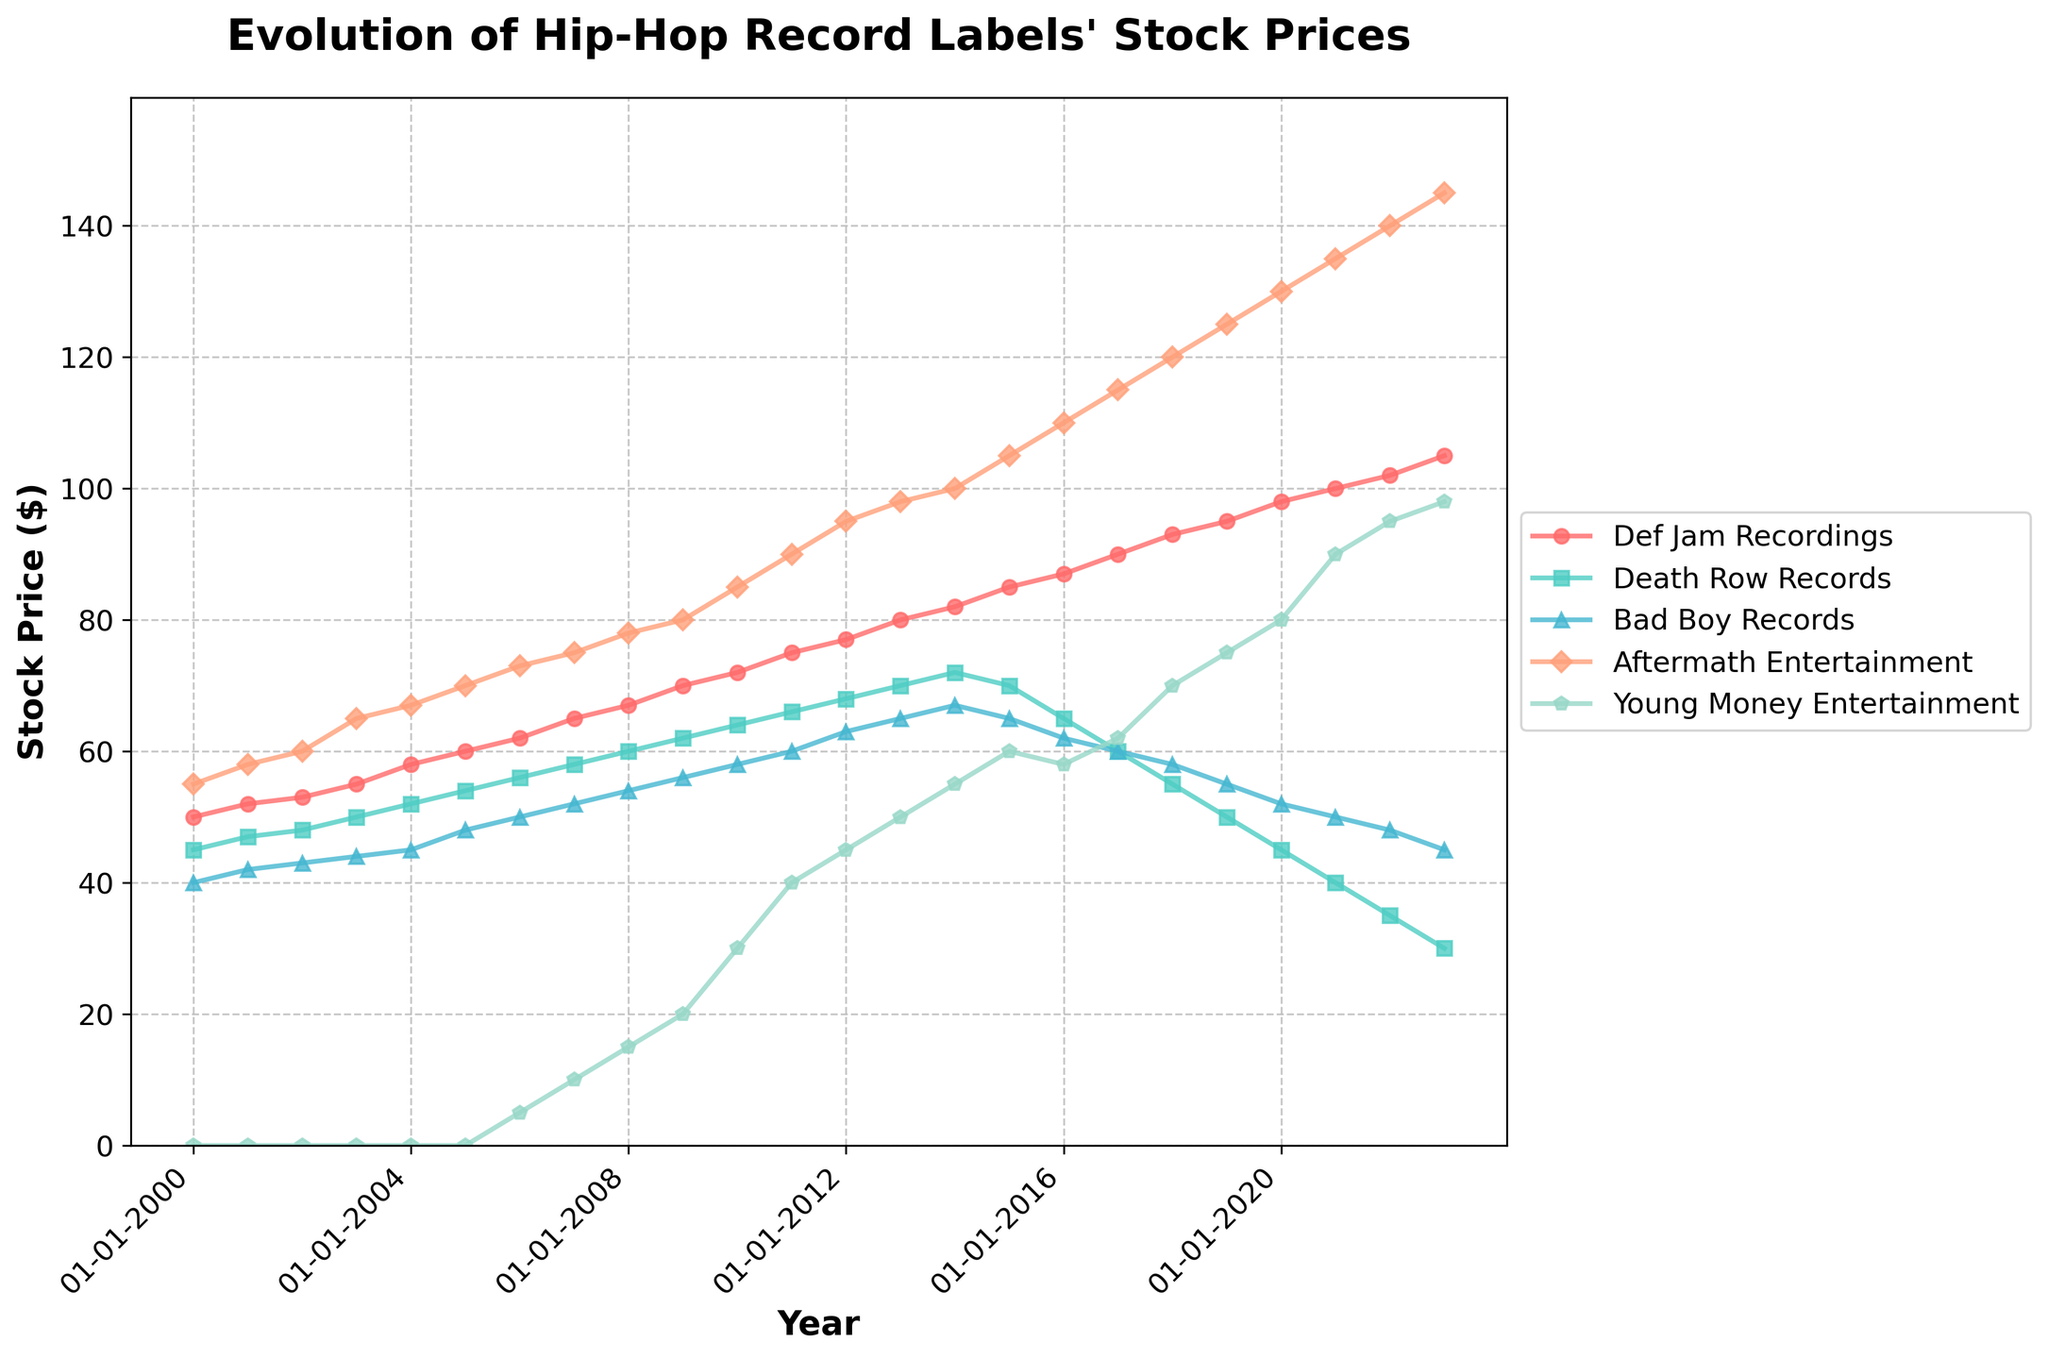What's the title of the figure? The title is typically located at the top of the figure and describes what the plot represents. In this case, it reads "Evolution of Hip-Hop Record Labels' Stock Prices".
Answer: Evolution of Hip-Hop Record Labels' Stock Prices Which record label shows a consistent yearly increase in stock price from 2000 to 2023? By observing the trends in the lines, Def Jam Recordings displays a consistent increase in stock price every year from 2000 to 2023.
Answer: Def Jam Recordings What is the stock price of Young Money Entertainment in 2006? Locate the point on the plot corresponding to the year 2006 along the x-axis and trace it to the Young Money Entertainment plot line. The stock price in 2006 is marked around 5.
Answer: 5 In what year did Aftermath Entertainment experience the highest stock price? Identify the highest point on the Aftermath Entertainment line and trace it back to the x-axis to find the corresponding year. The highest point occurs in 2023.
Answer: 2023 How does the stock price trend of Death Row Records change from 2010 to 2023? From 2010 onwards, Death Row Records shows a noticeable decline in stock price. Trace the plot line for Death Row Records from 2010, observing the continuous decrease until it reaches its lowest in 2023.
Answer: Continuous decline Between 2000 and 2023, which record label had the highest overall stock price increase, and by how much? Calculate the differences between the stock prices in 2023 and 2000 for each label and find the largest. Def Jam Recordings increased from 50 to 105, an increase of 55, Death Row Records decreased, Bad Boy Records increased from 40 to 45, an increase of 5, Aftermath Entertainment increased from 55 to 145, an increase of 90, and Young Money Entertainment increased from 0 to 98, an increase of 98. Aftermath Entertainment's increase of 90 is the highest.
Answer: Aftermath Entertainment, 90 Which record label had its stock price peak in 2019? Check the highest points in the plot lines and note which lines peak at 2019. Aftermath Entertainment shows a stock price peak in 2019.
Answer: Aftermath Entertainment Compare the stock price trends of Bad Boy Records and Young Money Entertainment from 2010 to 2023. From 2010, Young Money Entertainment shows a rapid increase from 30 to 98. Bad Boy Records, however, shows a general decline from 58 to 45.
Answer: Young Money Entertainment increased, Bad Boy Records declined What was the stock price of Def Jam Recordings in 2020? Locate the point on the Def Jam Recordings line for the year 2020 and read the stock price off the y-axis. The price is around 98.
Answer: 98 From 2018 to 2023, which two record labels showed contrasting stock price trends? Analyze the plot lines between 2018 and 2023. Def Jam Recordings shows an upward trend, increasing from 93 to 105. Conversely, Death Row Records shows a downward trend, decreasing from 55 to 30.
Answer: Def Jam Recordings, Death Row Records 